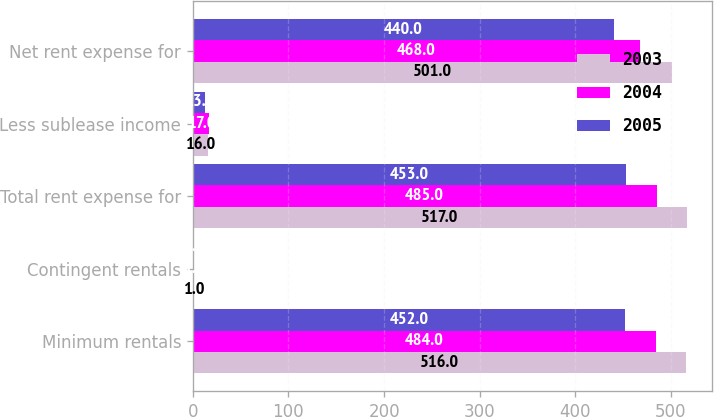Convert chart. <chart><loc_0><loc_0><loc_500><loc_500><stacked_bar_chart><ecel><fcel>Minimum rentals<fcel>Contingent rentals<fcel>Total rent expense for<fcel>Less sublease income<fcel>Net rent expense for<nl><fcel>2003<fcel>516<fcel>1<fcel>517<fcel>16<fcel>501<nl><fcel>2004<fcel>484<fcel>1<fcel>485<fcel>17<fcel>468<nl><fcel>2005<fcel>452<fcel>1<fcel>453<fcel>13<fcel>440<nl></chart> 